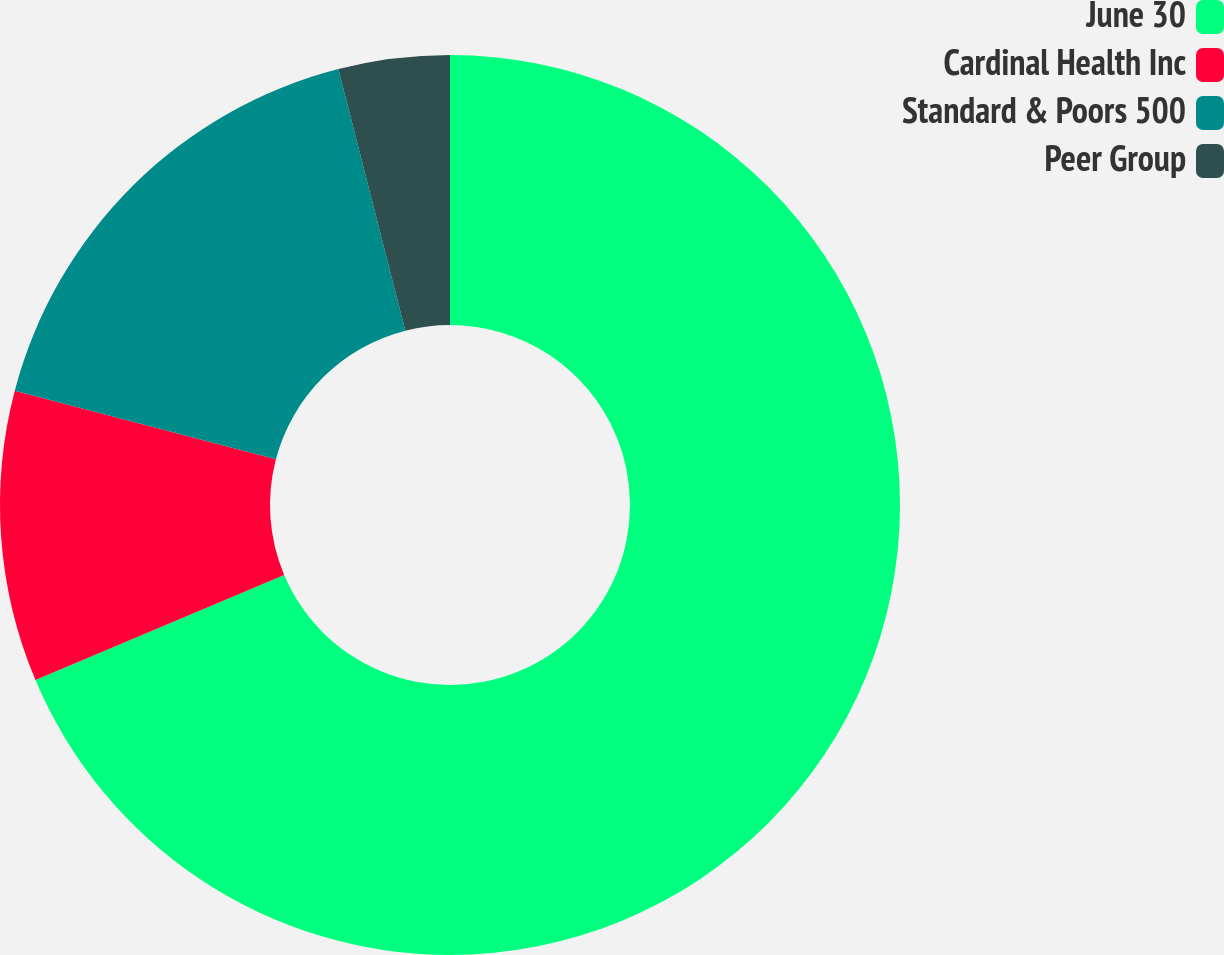Convert chart to OTSL. <chart><loc_0><loc_0><loc_500><loc_500><pie_chart><fcel>June 30<fcel>Cardinal Health Inc<fcel>Standard & Poors 500<fcel>Peer Group<nl><fcel>68.64%<fcel>10.45%<fcel>16.92%<fcel>3.99%<nl></chart> 